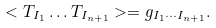Convert formula to latex. <formula><loc_0><loc_0><loc_500><loc_500>< T _ { I _ { 1 } } \dots T _ { I _ { n + 1 } } > = g _ { I _ { 1 } \cdots I _ { n + 1 } } .</formula> 